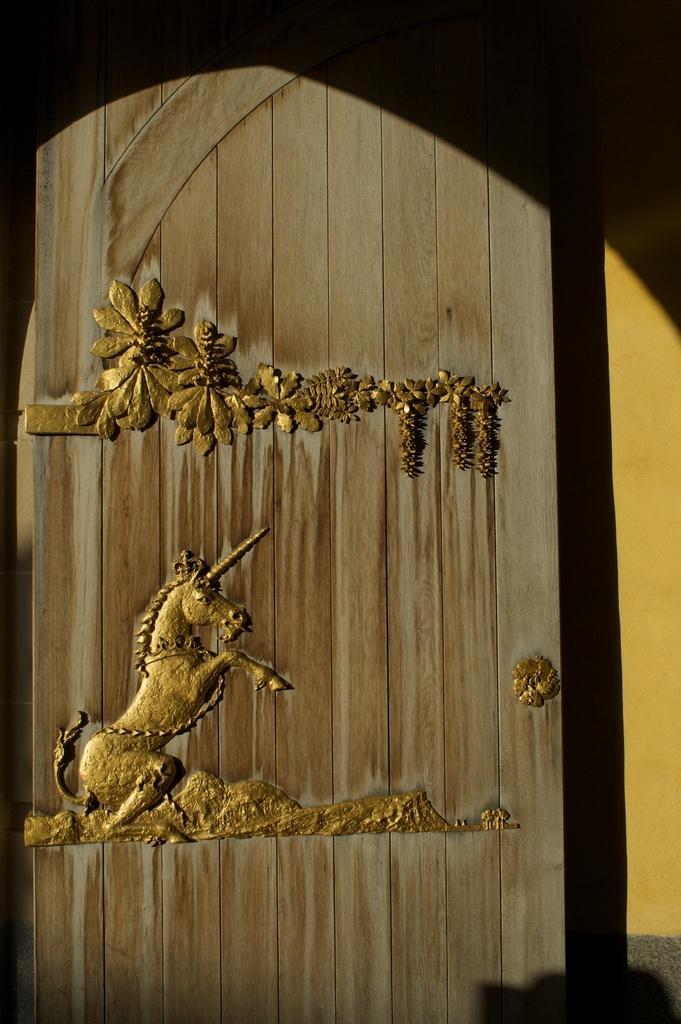In one or two sentences, can you explain what this image depicts? In this image there is an art of a horse and some plants on the door. 